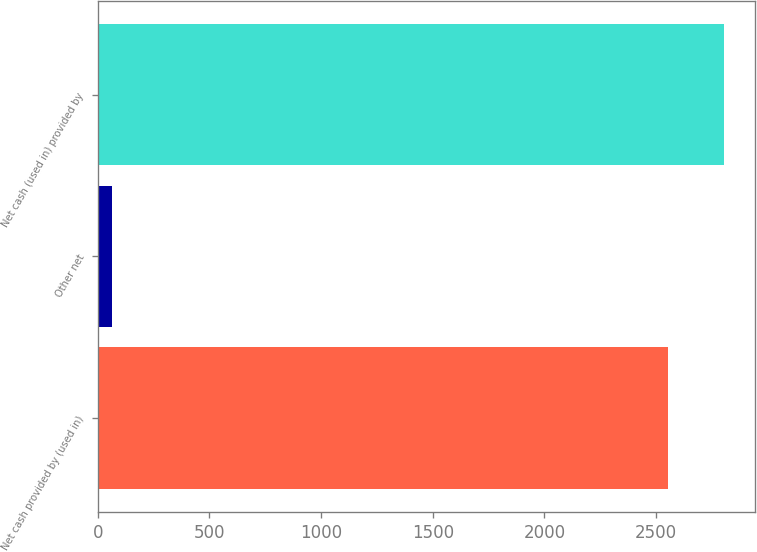Convert chart. <chart><loc_0><loc_0><loc_500><loc_500><bar_chart><fcel>Net cash provided by (used in)<fcel>Other net<fcel>Net cash (used in) provided by<nl><fcel>2554<fcel>65<fcel>2802.9<nl></chart> 